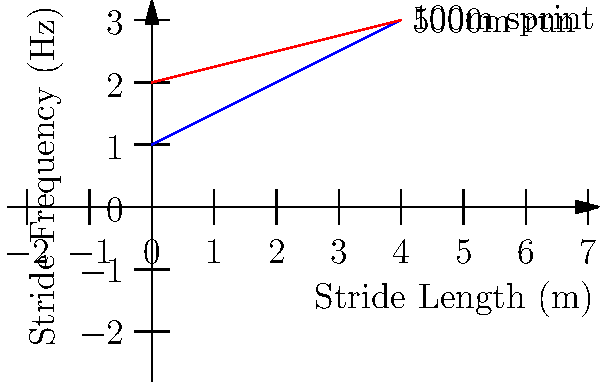The graph shows the relationship between stride length and stride frequency for a 100m sprint and a 5000m run. If a runner maintains a stride length of 2.5m in the 100m sprint, what would be the difference in stride frequency between the 100m sprint and the 5000m run at this stride length? To solve this problem, we need to follow these steps:

1. Identify the equations for each line:
   - 100m sprint: $y = 0.5x + 1$
   - 5000m run: $y = 0.25x + 2$

2. Calculate the stride frequency for the 100m sprint at 2.5m stride length:
   $y = 0.5(2.5) + 1 = 1.25 + 1 = 2.25$ Hz

3. Calculate the stride frequency for the 5000m run at 2.5m stride length:
   $y = 0.25(2.5) + 2 = 0.625 + 2 = 2.625$ Hz

4. Find the difference between the two stride frequencies:
   $2.625 - 2.25 = 0.375$ Hz

Therefore, the difference in stride frequency between the 5000m run and the 100m sprint at a stride length of 2.5m is 0.375 Hz.
Answer: 0.375 Hz 